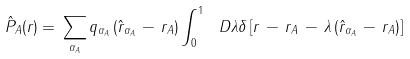<formula> <loc_0><loc_0><loc_500><loc_500>\hat { P } _ { A } ( { r } ) = \, \sum _ { \alpha _ { A } } q _ { \alpha _ { A } } \left ( \hat { r } _ { \alpha _ { A } } \, - \, { r } _ { A } \right ) \int _ { 0 } ^ { 1 } \ D \lambda \delta \left [ { r } \, - \, { r } _ { A } \, - \, \lambda \left ( \hat { r } _ { \alpha _ { A } } \, - \, { r } _ { A } \right ) \right ]</formula> 